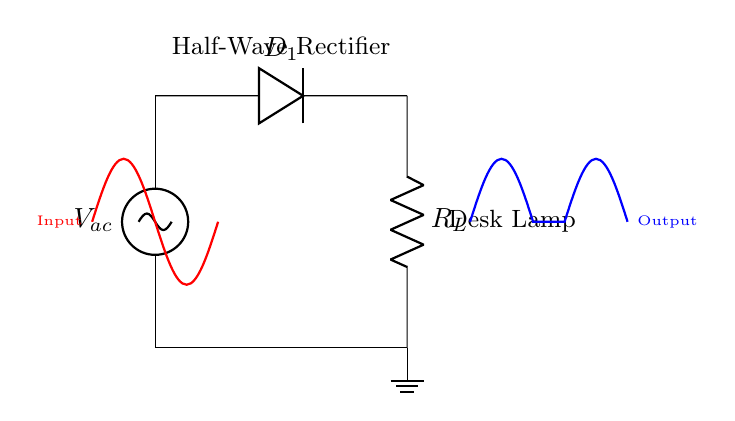What is the type of rectifier shown in the diagram? The diagram represents a half-wave rectifier, as indicated in the title and the configuration of components (one diode).
Answer: half-wave rectifier What component is used to convert AC to DC in this circuit? The diode, labeled D1 in the diagram, is the component that allows current to flow in one direction, thereby converting AC to DC.
Answer: diode What is the load in this circuit? The load in this half-wave rectifier circuit is represented by the resistor, labeled RL, which powers the desk lamp.
Answer: desk lamp What happens to the negative half of the AC waveform? In a half-wave rectifier, the negative half of the AC waveform is blocked by the diode, resulting in only the positive half being passed to the load.
Answer: blocked What does the output waveform look like compared to the input? The output waveform appears as a series of positive pulses corresponding to the positive half-cycles of the input waveform, while the negative half-cycles are absent.
Answer: positive pulses What occurs when no load is connected to the output? If no load is connected to the output, the circuit is open and no current flows through the circuit, resulting in no output voltage across RL.
Answer: no current flows 